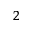Convert formula to latex. <formula><loc_0><loc_0><loc_500><loc_500>^ { 2 }</formula> 